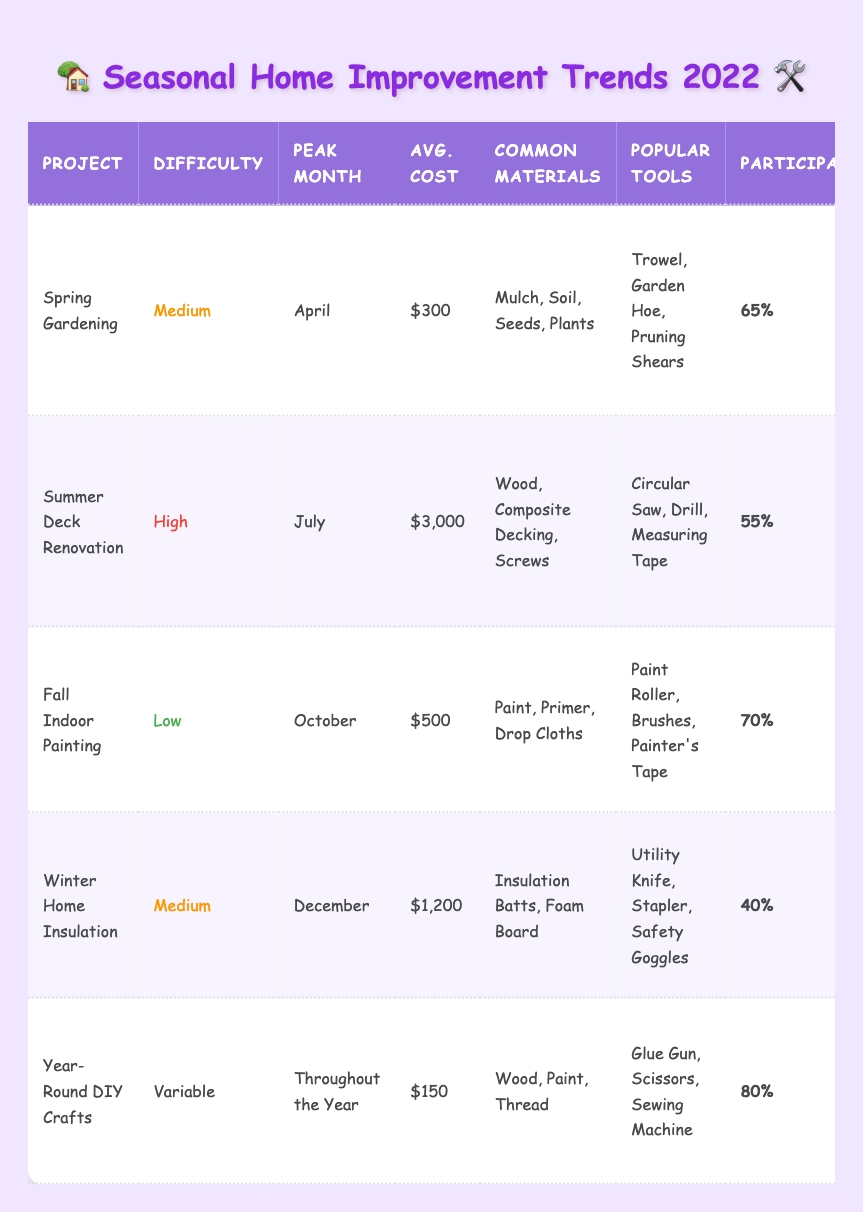What's the average cost of Spring Gardening? The average cost of Spring Gardening is listed directly in the table, which is $300.
Answer: $300 Which project has the highest participation rate? The participation rates for each project are: Spring Gardening (65%), Summer Deck Renovation (55%), Fall Indoor Painting (70%), Winter Home Insulation (40%), and Year-Round DIY Crafts (80%). The highest is Year-Round DIY Crafts at 80%.
Answer: Year-Round DIY Crafts In which month does the Fall Indoor Painting project peak? The peak month for Fall Indoor Painting can be found in the corresponding row in the table, which states it peaks in October.
Answer: October Are the common materials for Winter Home Insulation the same as those for Summer Deck Renovation? The common materials for Winter Home Insulation are "Insulation Batts, Foam Board" and for Summer Deck Renovation are "Wood, Composite Decking, Screws." These lists differ; therefore, the answer is no.
Answer: No What is the total average cost of the Spring Gardening and Fall Indoor Painting projects? The average cost of Spring Gardening is $300, and for Fall Indoor Painting, it is $500. Adding these together gives $300 + $500 = $800, so the total is $800.
Answer: $800 How many projects have a difficulty level classified as Medium? From the table, Spring Gardening and Winter Home Insulation have a difficulty level of Medium. Thus, there are 2 such projects.
Answer: 2 What materials are common for Year-Round DIY Crafts? The common materials for Year-Round DIY Crafts are listed in the table as "Wood, Paint, Thread." This can be found directly in that project’s row.
Answer: Wood, Paint, Thread Is the average cost of the Summer Deck Renovation project more than twice the cost of the Spring Gardening project? The average cost of Summer Deck Renovation is $3000 and of Spring Gardening is $300. Twice the cost of Spring Gardening is $300 x 2 = $600. Since $3000 is greater than $600, the answer is yes.
Answer: Yes If we consider the participation rates, which season is most engaging based on the provided data? The participation rates show that Year-Round DIY Crafts (80%) has the highest engagement, and this is a year-round project, overshadowing Spring, Summer, Fall, and Winter projects in terms of participation.
Answer: Year-Round DIY Crafts What is the difference between the participation rates of Fall Indoor Painting and Winter Home Insulation? The participation rate for Fall Indoor Painting is 70%, and for Winter Home Insulation, it's 40%. To find the difference, subtract 40% from 70%, which gives 70% - 40% = 30%.
Answer: 30% 